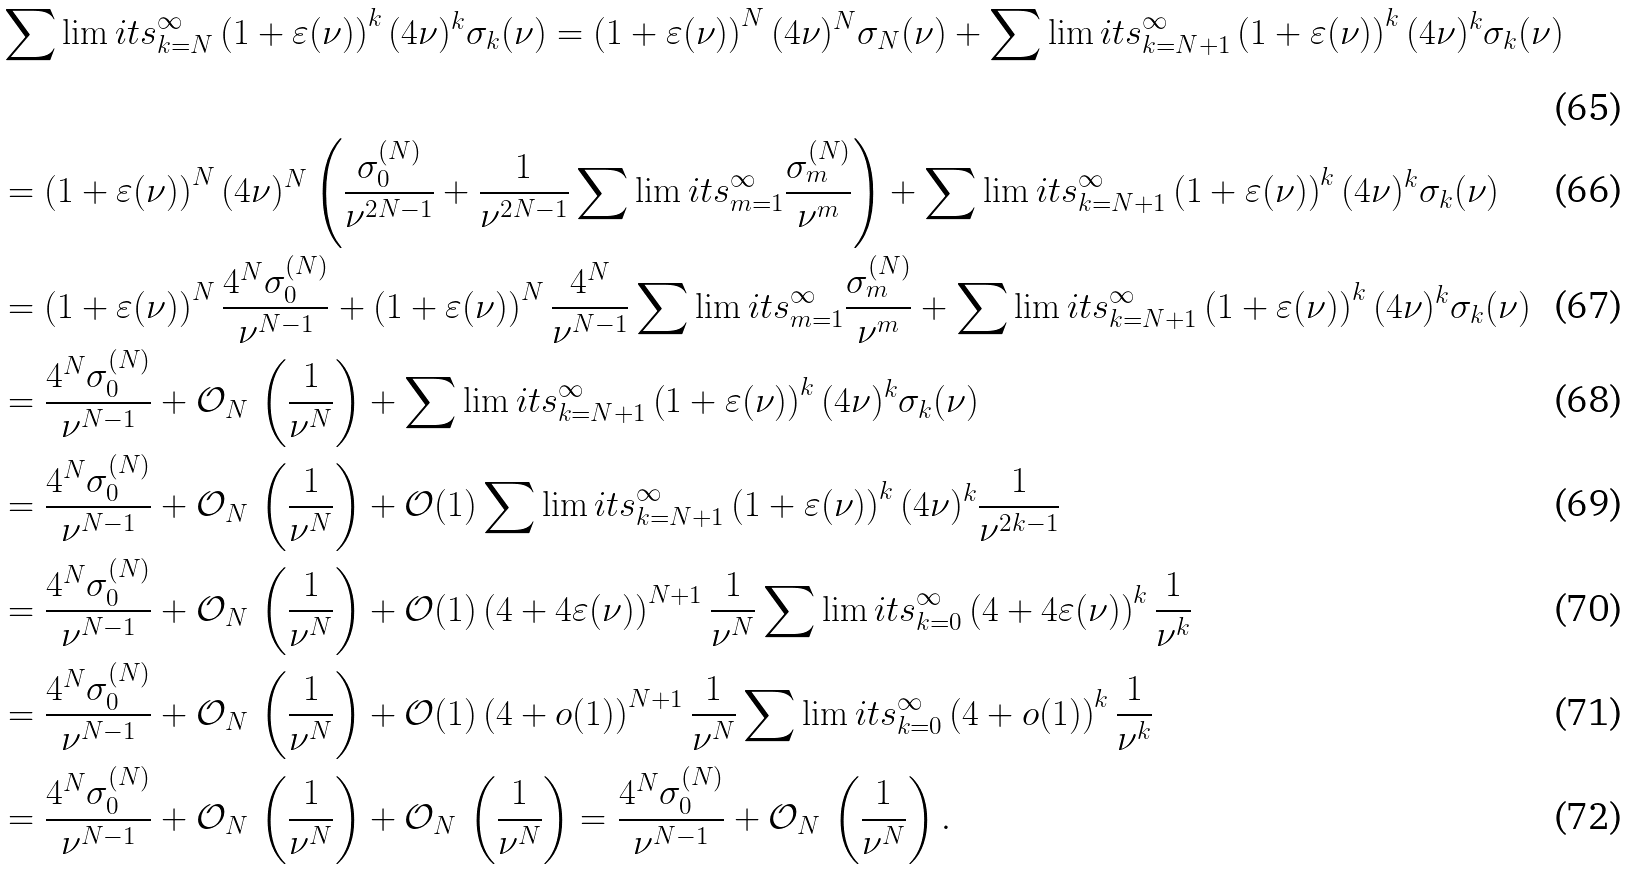Convert formula to latex. <formula><loc_0><loc_0><loc_500><loc_500>& \sum \lim i t s _ { k = N } ^ { \infty } \left ( 1 + \varepsilon ( \nu ) \right ) ^ { k } ( 4 \nu ) ^ { k } \sigma _ { k } ( \nu ) = \left ( 1 + \varepsilon ( \nu ) \right ) ^ { N } ( 4 \nu ) ^ { N } \sigma _ { N } ( \nu ) + \sum \lim i t s _ { k = N + 1 } ^ { \infty } \left ( 1 + \varepsilon ( \nu ) \right ) ^ { k } ( 4 \nu ) ^ { k } \sigma _ { k } ( \nu ) \\ & = \left ( 1 + \varepsilon ( \nu ) \right ) ^ { N } ( 4 \nu ) ^ { N } \left ( \frac { \sigma _ { 0 } ^ { ( N ) } } { \nu ^ { 2 N - 1 } } + \frac { 1 } { \nu ^ { 2 N - 1 } } \sum \lim i t s _ { m = 1 } ^ { \infty } \frac { \sigma _ { m } ^ { ( N ) } } { \nu ^ { m } } \right ) + \sum \lim i t s _ { k = N + 1 } ^ { \infty } \left ( 1 + \varepsilon ( \nu ) \right ) ^ { k } ( 4 \nu ) ^ { k } \sigma _ { k } ( \nu ) \\ & = \left ( 1 + \varepsilon ( \nu ) \right ) ^ { N } \frac { 4 ^ { N } \sigma _ { 0 } ^ { ( N ) } } { \nu ^ { N - 1 } } + \left ( 1 + \varepsilon ( \nu ) \right ) ^ { N } \frac { 4 ^ { N } } { \nu ^ { N - 1 } } \sum \lim i t s _ { m = 1 } ^ { \infty } \frac { \sigma _ { m } ^ { ( N ) } } { \nu ^ { m } } + \sum \lim i t s _ { k = N + 1 } ^ { \infty } \left ( 1 + \varepsilon ( \nu ) \right ) ^ { k } ( 4 \nu ) ^ { k } \sigma _ { k } ( \nu ) \\ & = \frac { 4 ^ { N } \sigma _ { 0 } ^ { ( N ) } } { \nu ^ { N - 1 } } + \mathcal { O } _ { N } \, \left ( \frac { 1 } { \nu ^ { N } } \right ) + \sum \lim i t s _ { k = N + 1 } ^ { \infty } \left ( 1 + \varepsilon ( \nu ) \right ) ^ { k } ( 4 \nu ) ^ { k } \sigma _ { k } ( \nu ) \\ & = \frac { 4 ^ { N } \sigma _ { 0 } ^ { ( N ) } } { \nu ^ { N - 1 } } + \mathcal { O } _ { N } \, \left ( \frac { 1 } { \nu ^ { N } } \right ) + \mathcal { O } ( 1 ) \sum \lim i t s _ { k = N + 1 } ^ { \infty } \left ( 1 + \varepsilon ( \nu ) \right ) ^ { k } ( 4 \nu ) ^ { k } \frac { 1 } { \nu ^ { 2 k - 1 } } \\ & = \frac { 4 ^ { N } \sigma _ { 0 } ^ { ( N ) } } { \nu ^ { N - 1 } } + \mathcal { O } _ { N } \, \left ( \frac { 1 } { \nu ^ { N } } \right ) + \mathcal { O } ( 1 ) \left ( 4 + 4 \varepsilon ( \nu ) \right ) ^ { N + 1 } \frac { 1 } { \nu ^ { N } } \sum \lim i t s _ { k = 0 } ^ { \infty } \left ( 4 + 4 \varepsilon ( \nu ) \right ) ^ { k } \frac { 1 } { \nu ^ { k } } \\ & = \frac { 4 ^ { N } \sigma _ { 0 } ^ { ( N ) } } { \nu ^ { N - 1 } } + \mathcal { O } _ { N } \, \left ( \frac { 1 } { \nu ^ { N } } \right ) + \mathcal { O } ( 1 ) \left ( 4 + o ( 1 ) \right ) ^ { N + 1 } \frac { 1 } { \nu ^ { N } } \sum \lim i t s _ { k = 0 } ^ { \infty } \left ( 4 + o ( 1 ) \right ) ^ { k } \frac { 1 } { \nu ^ { k } } \\ & = \frac { 4 ^ { N } \sigma _ { 0 } ^ { ( N ) } } { \nu ^ { N - 1 } } + \mathcal { O } _ { N } \, \left ( \frac { 1 } { \nu ^ { N } } \right ) + \mathcal { O } _ { N } \, \left ( \frac { 1 } { \nu ^ { N } } \right ) = \frac { 4 ^ { N } \sigma _ { 0 } ^ { ( N ) } } { \nu ^ { N - 1 } } + \mathcal { O } _ { N } \, \left ( \frac { 1 } { \nu ^ { N } } \right ) .</formula> 